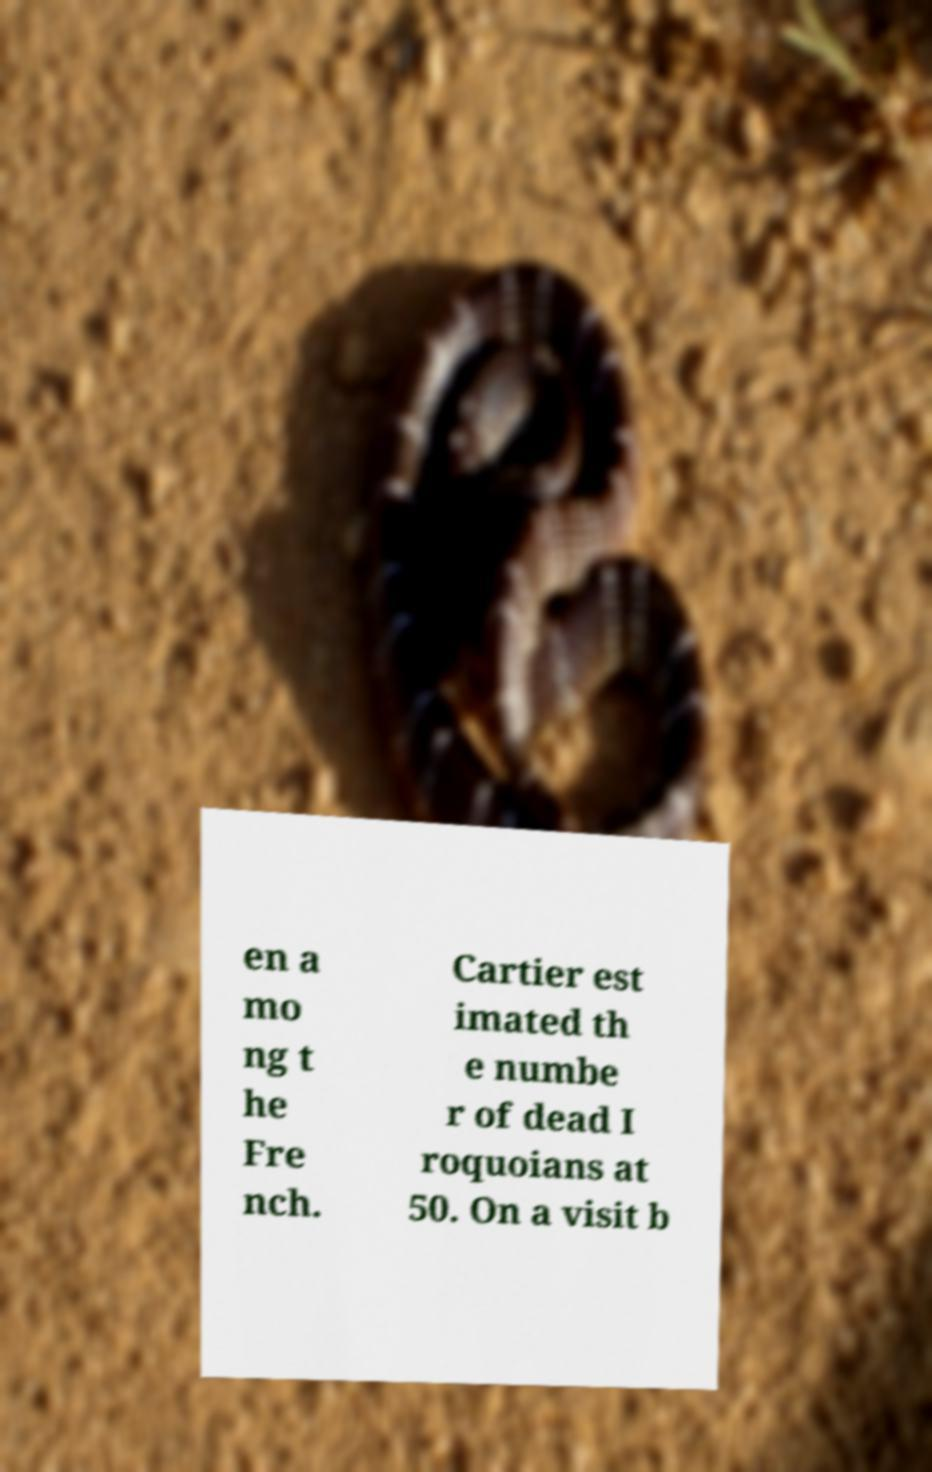What messages or text are displayed in this image? I need them in a readable, typed format. en a mo ng t he Fre nch. Cartier est imated th e numbe r of dead I roquoians at 50. On a visit b 